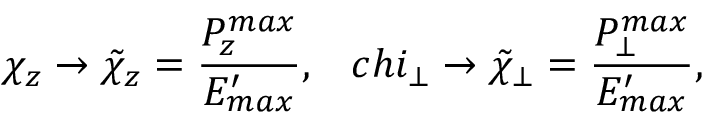<formula> <loc_0><loc_0><loc_500><loc_500>\chi _ { z } \rightarrow \tilde { \chi } _ { z } = \frac { P _ { z } ^ { \max } } { E _ { \max } ^ { \prime } } , \quad , c h i _ { \bot } \rightarrow \tilde { \chi } _ { \bot } = \frac { P _ { \bot } ^ { \max } } { E _ { \max } ^ { \prime } } ,</formula> 